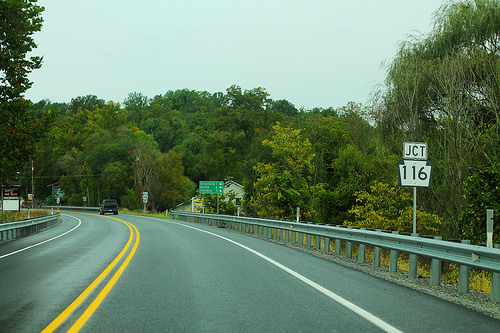<image>
Can you confirm if the sign is behind the house? No. The sign is not behind the house. From this viewpoint, the sign appears to be positioned elsewhere in the scene. 